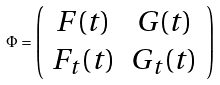<formula> <loc_0><loc_0><loc_500><loc_500>\Phi = \left ( \begin{array} { c c } F ( t ) & G ( t ) \\ F _ { t } ( t ) & G _ { t } ( t ) \end{array} \right )</formula> 